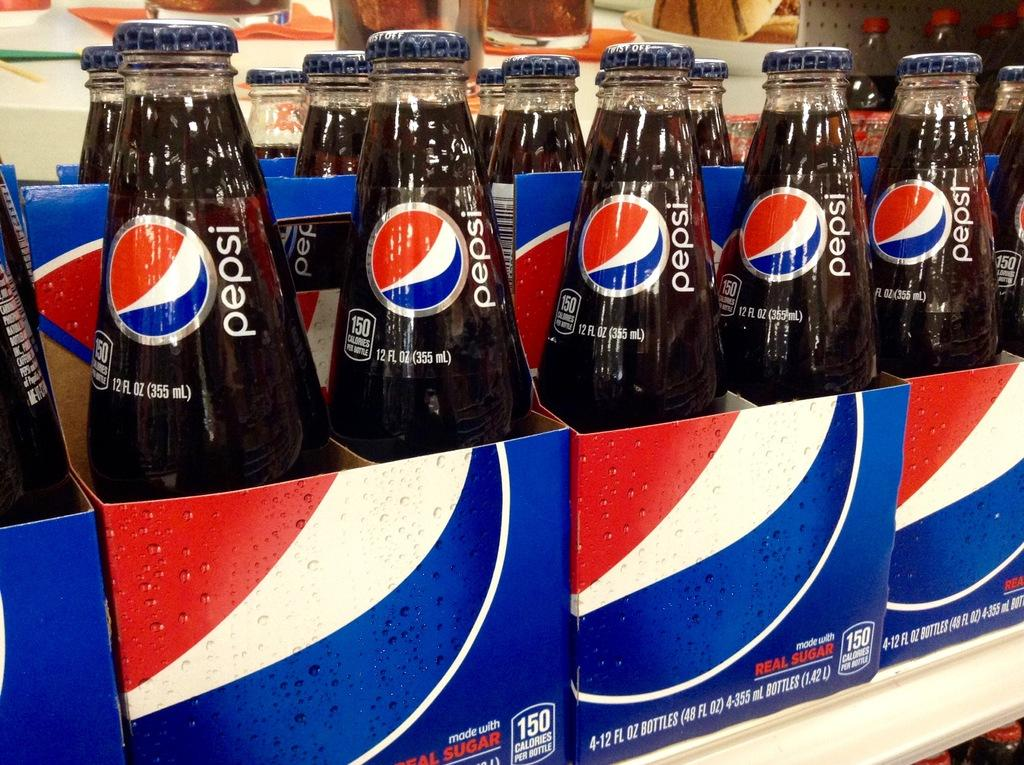<image>
Share a concise interpretation of the image provided. A shelf containing many six-packs of Pepsi bottles 